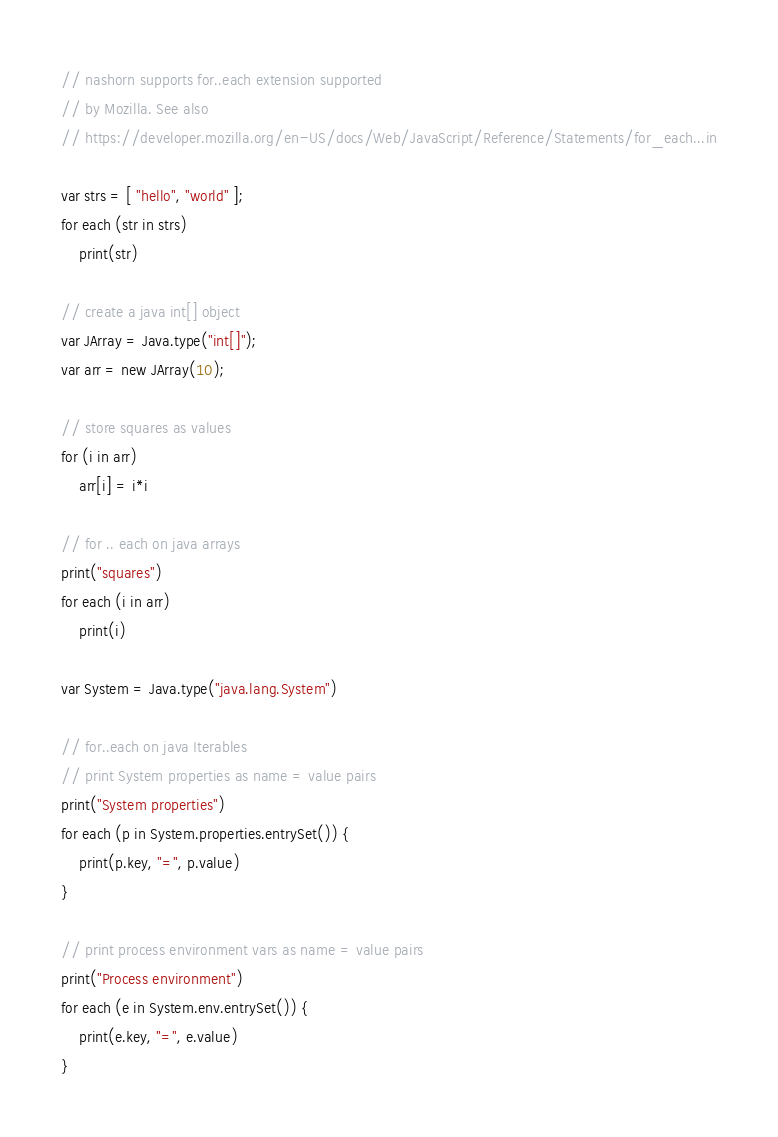Convert code to text. <code><loc_0><loc_0><loc_500><loc_500><_JavaScript_>// nashorn supports for..each extension supported
// by Mozilla. See also
// https://developer.mozilla.org/en-US/docs/Web/JavaScript/Reference/Statements/for_each...in

var strs = [ "hello", "world" ];
for each (str in strs)
    print(str)

// create a java int[] object
var JArray = Java.type("int[]");
var arr = new JArray(10);

// store squares as values
for (i in arr) 
    arr[i] = i*i

// for .. each on java arrays
print("squares")
for each (i in arr)
    print(i)

var System = Java.type("java.lang.System")

// for..each on java Iterables
// print System properties as name = value pairs
print("System properties")
for each (p in System.properties.entrySet()) {
    print(p.key, "=", p.value)
} 

// print process environment vars as name = value pairs
print("Process environment")
for each (e in System.env.entrySet()) {
    print(e.key, "=", e.value)
}
</code> 